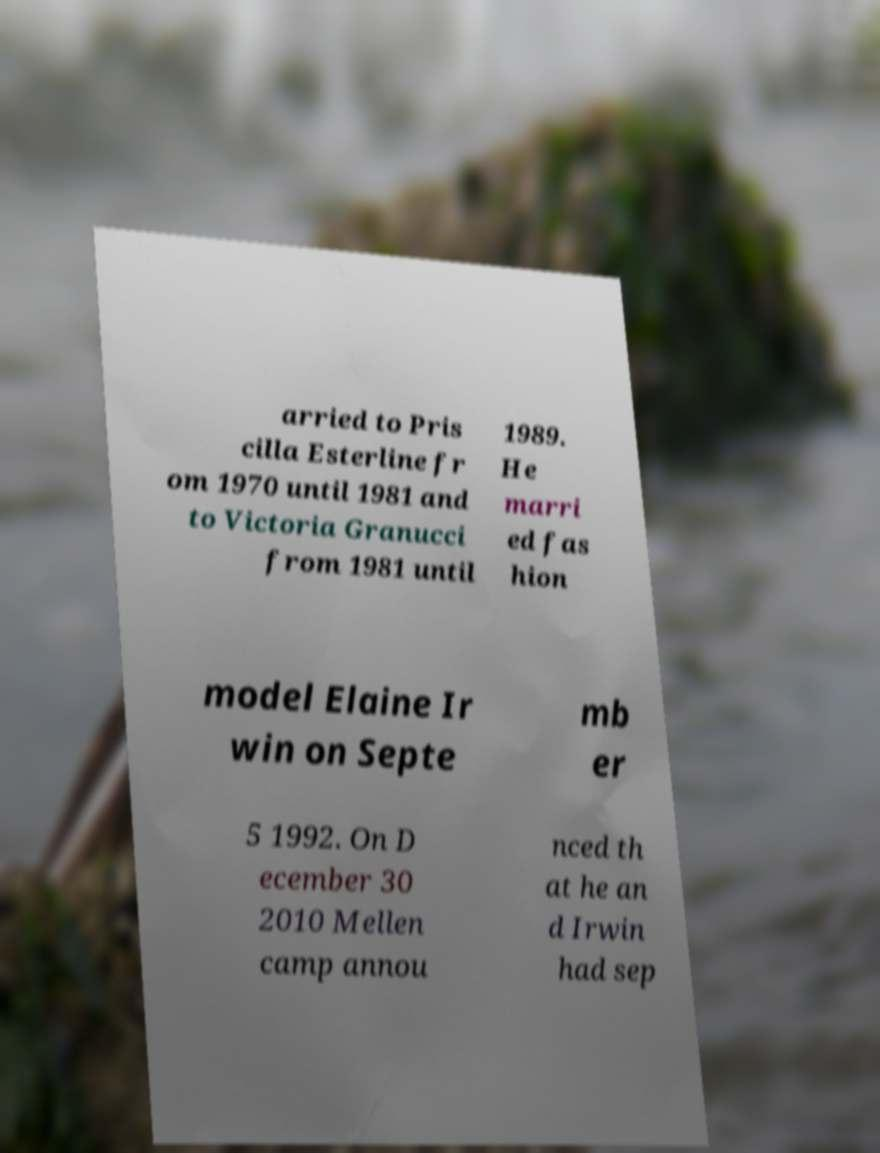Could you assist in decoding the text presented in this image and type it out clearly? arried to Pris cilla Esterline fr om 1970 until 1981 and to Victoria Granucci from 1981 until 1989. He marri ed fas hion model Elaine Ir win on Septe mb er 5 1992. On D ecember 30 2010 Mellen camp annou nced th at he an d Irwin had sep 